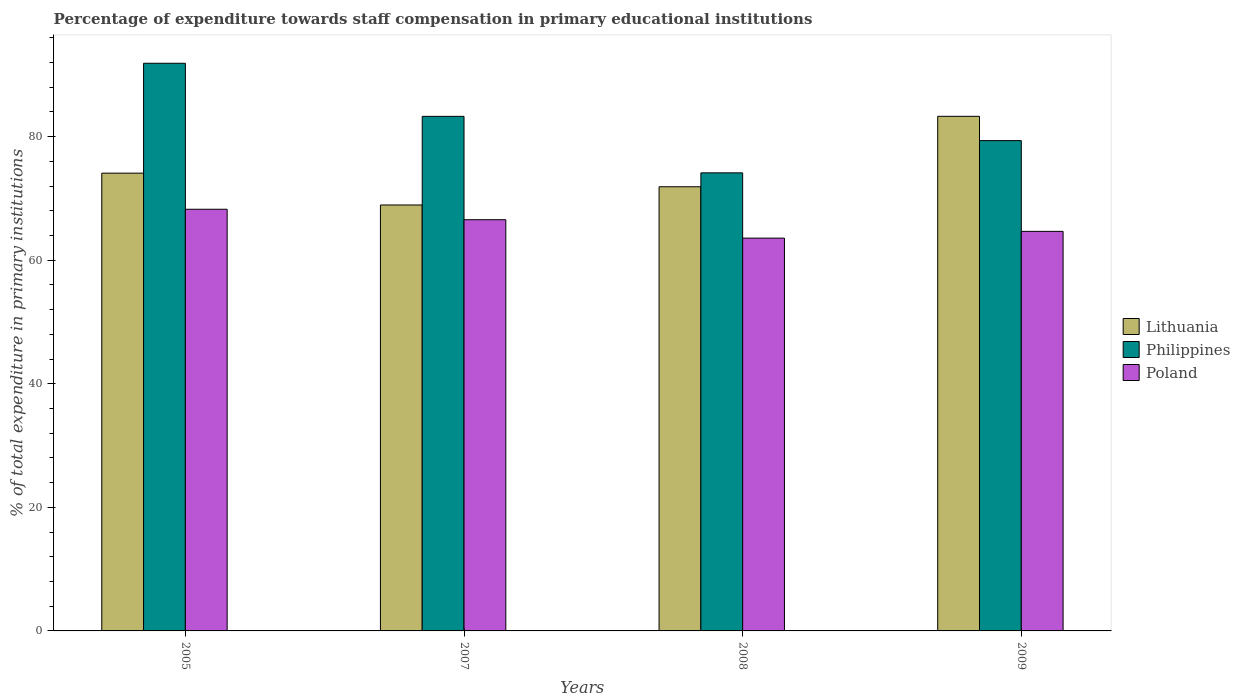How many different coloured bars are there?
Ensure brevity in your answer.  3. How many groups of bars are there?
Give a very brief answer. 4. Are the number of bars per tick equal to the number of legend labels?
Provide a succinct answer. Yes. Are the number of bars on each tick of the X-axis equal?
Offer a very short reply. Yes. What is the label of the 1st group of bars from the left?
Ensure brevity in your answer.  2005. What is the percentage of expenditure towards staff compensation in Poland in 2005?
Make the answer very short. 68.25. Across all years, what is the maximum percentage of expenditure towards staff compensation in Lithuania?
Keep it short and to the point. 83.29. Across all years, what is the minimum percentage of expenditure towards staff compensation in Lithuania?
Provide a succinct answer. 68.94. In which year was the percentage of expenditure towards staff compensation in Poland maximum?
Your answer should be compact. 2005. What is the total percentage of expenditure towards staff compensation in Poland in the graph?
Provide a short and direct response. 263.04. What is the difference between the percentage of expenditure towards staff compensation in Philippines in 2007 and that in 2008?
Make the answer very short. 9.14. What is the difference between the percentage of expenditure towards staff compensation in Philippines in 2007 and the percentage of expenditure towards staff compensation in Poland in 2009?
Offer a terse response. 18.61. What is the average percentage of expenditure towards staff compensation in Lithuania per year?
Your answer should be compact. 74.55. In the year 2008, what is the difference between the percentage of expenditure towards staff compensation in Philippines and percentage of expenditure towards staff compensation in Lithuania?
Your answer should be very brief. 2.25. In how many years, is the percentage of expenditure towards staff compensation in Lithuania greater than 76 %?
Ensure brevity in your answer.  1. What is the ratio of the percentage of expenditure towards staff compensation in Lithuania in 2008 to that in 2009?
Give a very brief answer. 0.86. What is the difference between the highest and the second highest percentage of expenditure towards staff compensation in Philippines?
Make the answer very short. 8.59. What is the difference between the highest and the lowest percentage of expenditure towards staff compensation in Lithuania?
Your answer should be very brief. 14.35. In how many years, is the percentage of expenditure towards staff compensation in Philippines greater than the average percentage of expenditure towards staff compensation in Philippines taken over all years?
Offer a terse response. 2. What does the 3rd bar from the right in 2009 represents?
Your answer should be compact. Lithuania. How many bars are there?
Your response must be concise. 12. Are all the bars in the graph horizontal?
Keep it short and to the point. No. How many years are there in the graph?
Offer a terse response. 4. Are the values on the major ticks of Y-axis written in scientific E-notation?
Provide a succinct answer. No. How are the legend labels stacked?
Your answer should be very brief. Vertical. What is the title of the graph?
Provide a short and direct response. Percentage of expenditure towards staff compensation in primary educational institutions. What is the label or title of the X-axis?
Give a very brief answer. Years. What is the label or title of the Y-axis?
Keep it short and to the point. % of total expenditure in primary institutions. What is the % of total expenditure in primary institutions in Lithuania in 2005?
Ensure brevity in your answer.  74.09. What is the % of total expenditure in primary institutions in Philippines in 2005?
Ensure brevity in your answer.  91.88. What is the % of total expenditure in primary institutions of Poland in 2005?
Provide a succinct answer. 68.25. What is the % of total expenditure in primary institutions in Lithuania in 2007?
Provide a succinct answer. 68.94. What is the % of total expenditure in primary institutions in Philippines in 2007?
Offer a very short reply. 83.28. What is the % of total expenditure in primary institutions in Poland in 2007?
Make the answer very short. 66.55. What is the % of total expenditure in primary institutions of Lithuania in 2008?
Your answer should be very brief. 71.89. What is the % of total expenditure in primary institutions in Philippines in 2008?
Offer a very short reply. 74.14. What is the % of total expenditure in primary institutions in Poland in 2008?
Ensure brevity in your answer.  63.57. What is the % of total expenditure in primary institutions of Lithuania in 2009?
Your response must be concise. 83.29. What is the % of total expenditure in primary institutions of Philippines in 2009?
Offer a very short reply. 79.35. What is the % of total expenditure in primary institutions in Poland in 2009?
Keep it short and to the point. 64.67. Across all years, what is the maximum % of total expenditure in primary institutions of Lithuania?
Make the answer very short. 83.29. Across all years, what is the maximum % of total expenditure in primary institutions of Philippines?
Your response must be concise. 91.88. Across all years, what is the maximum % of total expenditure in primary institutions of Poland?
Offer a very short reply. 68.25. Across all years, what is the minimum % of total expenditure in primary institutions of Lithuania?
Keep it short and to the point. 68.94. Across all years, what is the minimum % of total expenditure in primary institutions of Philippines?
Provide a succinct answer. 74.14. Across all years, what is the minimum % of total expenditure in primary institutions of Poland?
Provide a short and direct response. 63.57. What is the total % of total expenditure in primary institutions of Lithuania in the graph?
Provide a short and direct response. 298.2. What is the total % of total expenditure in primary institutions of Philippines in the graph?
Ensure brevity in your answer.  328.65. What is the total % of total expenditure in primary institutions in Poland in the graph?
Offer a very short reply. 263.04. What is the difference between the % of total expenditure in primary institutions of Lithuania in 2005 and that in 2007?
Keep it short and to the point. 5.15. What is the difference between the % of total expenditure in primary institutions of Philippines in 2005 and that in 2007?
Keep it short and to the point. 8.59. What is the difference between the % of total expenditure in primary institutions of Poland in 2005 and that in 2007?
Your response must be concise. 1.69. What is the difference between the % of total expenditure in primary institutions of Lithuania in 2005 and that in 2008?
Your response must be concise. 2.2. What is the difference between the % of total expenditure in primary institutions in Philippines in 2005 and that in 2008?
Give a very brief answer. 17.74. What is the difference between the % of total expenditure in primary institutions of Poland in 2005 and that in 2008?
Provide a short and direct response. 4.67. What is the difference between the % of total expenditure in primary institutions in Lithuania in 2005 and that in 2009?
Provide a succinct answer. -9.2. What is the difference between the % of total expenditure in primary institutions of Philippines in 2005 and that in 2009?
Keep it short and to the point. 12.52. What is the difference between the % of total expenditure in primary institutions in Poland in 2005 and that in 2009?
Provide a succinct answer. 3.58. What is the difference between the % of total expenditure in primary institutions of Lithuania in 2007 and that in 2008?
Make the answer very short. -2.95. What is the difference between the % of total expenditure in primary institutions of Philippines in 2007 and that in 2008?
Offer a terse response. 9.14. What is the difference between the % of total expenditure in primary institutions in Poland in 2007 and that in 2008?
Offer a terse response. 2.98. What is the difference between the % of total expenditure in primary institutions in Lithuania in 2007 and that in 2009?
Provide a succinct answer. -14.35. What is the difference between the % of total expenditure in primary institutions in Philippines in 2007 and that in 2009?
Give a very brief answer. 3.93. What is the difference between the % of total expenditure in primary institutions of Poland in 2007 and that in 2009?
Give a very brief answer. 1.89. What is the difference between the % of total expenditure in primary institutions of Lithuania in 2008 and that in 2009?
Provide a succinct answer. -11.4. What is the difference between the % of total expenditure in primary institutions in Philippines in 2008 and that in 2009?
Keep it short and to the point. -5.22. What is the difference between the % of total expenditure in primary institutions in Poland in 2008 and that in 2009?
Your response must be concise. -1.09. What is the difference between the % of total expenditure in primary institutions of Lithuania in 2005 and the % of total expenditure in primary institutions of Philippines in 2007?
Offer a very short reply. -9.19. What is the difference between the % of total expenditure in primary institutions in Lithuania in 2005 and the % of total expenditure in primary institutions in Poland in 2007?
Give a very brief answer. 7.54. What is the difference between the % of total expenditure in primary institutions of Philippines in 2005 and the % of total expenditure in primary institutions of Poland in 2007?
Offer a terse response. 25.32. What is the difference between the % of total expenditure in primary institutions in Lithuania in 2005 and the % of total expenditure in primary institutions in Philippines in 2008?
Provide a short and direct response. -0.05. What is the difference between the % of total expenditure in primary institutions in Lithuania in 2005 and the % of total expenditure in primary institutions in Poland in 2008?
Ensure brevity in your answer.  10.51. What is the difference between the % of total expenditure in primary institutions of Philippines in 2005 and the % of total expenditure in primary institutions of Poland in 2008?
Give a very brief answer. 28.3. What is the difference between the % of total expenditure in primary institutions of Lithuania in 2005 and the % of total expenditure in primary institutions of Philippines in 2009?
Keep it short and to the point. -5.27. What is the difference between the % of total expenditure in primary institutions in Lithuania in 2005 and the % of total expenditure in primary institutions in Poland in 2009?
Your answer should be very brief. 9.42. What is the difference between the % of total expenditure in primary institutions of Philippines in 2005 and the % of total expenditure in primary institutions of Poland in 2009?
Your response must be concise. 27.21. What is the difference between the % of total expenditure in primary institutions of Lithuania in 2007 and the % of total expenditure in primary institutions of Philippines in 2008?
Your response must be concise. -5.2. What is the difference between the % of total expenditure in primary institutions in Lithuania in 2007 and the % of total expenditure in primary institutions in Poland in 2008?
Your answer should be compact. 5.36. What is the difference between the % of total expenditure in primary institutions of Philippines in 2007 and the % of total expenditure in primary institutions of Poland in 2008?
Your answer should be compact. 19.71. What is the difference between the % of total expenditure in primary institutions of Lithuania in 2007 and the % of total expenditure in primary institutions of Philippines in 2009?
Make the answer very short. -10.42. What is the difference between the % of total expenditure in primary institutions of Lithuania in 2007 and the % of total expenditure in primary institutions of Poland in 2009?
Make the answer very short. 4.27. What is the difference between the % of total expenditure in primary institutions in Philippines in 2007 and the % of total expenditure in primary institutions in Poland in 2009?
Keep it short and to the point. 18.61. What is the difference between the % of total expenditure in primary institutions of Lithuania in 2008 and the % of total expenditure in primary institutions of Philippines in 2009?
Give a very brief answer. -7.47. What is the difference between the % of total expenditure in primary institutions in Lithuania in 2008 and the % of total expenditure in primary institutions in Poland in 2009?
Your answer should be compact. 7.22. What is the difference between the % of total expenditure in primary institutions in Philippines in 2008 and the % of total expenditure in primary institutions in Poland in 2009?
Ensure brevity in your answer.  9.47. What is the average % of total expenditure in primary institutions in Lithuania per year?
Provide a short and direct response. 74.55. What is the average % of total expenditure in primary institutions of Philippines per year?
Ensure brevity in your answer.  82.16. What is the average % of total expenditure in primary institutions in Poland per year?
Your response must be concise. 65.76. In the year 2005, what is the difference between the % of total expenditure in primary institutions in Lithuania and % of total expenditure in primary institutions in Philippines?
Your answer should be very brief. -17.79. In the year 2005, what is the difference between the % of total expenditure in primary institutions in Lithuania and % of total expenditure in primary institutions in Poland?
Ensure brevity in your answer.  5.84. In the year 2005, what is the difference between the % of total expenditure in primary institutions of Philippines and % of total expenditure in primary institutions of Poland?
Your response must be concise. 23.63. In the year 2007, what is the difference between the % of total expenditure in primary institutions in Lithuania and % of total expenditure in primary institutions in Philippines?
Give a very brief answer. -14.34. In the year 2007, what is the difference between the % of total expenditure in primary institutions in Lithuania and % of total expenditure in primary institutions in Poland?
Offer a terse response. 2.38. In the year 2007, what is the difference between the % of total expenditure in primary institutions of Philippines and % of total expenditure in primary institutions of Poland?
Ensure brevity in your answer.  16.73. In the year 2008, what is the difference between the % of total expenditure in primary institutions in Lithuania and % of total expenditure in primary institutions in Philippines?
Your response must be concise. -2.25. In the year 2008, what is the difference between the % of total expenditure in primary institutions in Lithuania and % of total expenditure in primary institutions in Poland?
Your answer should be very brief. 8.31. In the year 2008, what is the difference between the % of total expenditure in primary institutions in Philippines and % of total expenditure in primary institutions in Poland?
Ensure brevity in your answer.  10.56. In the year 2009, what is the difference between the % of total expenditure in primary institutions in Lithuania and % of total expenditure in primary institutions in Philippines?
Keep it short and to the point. 3.93. In the year 2009, what is the difference between the % of total expenditure in primary institutions in Lithuania and % of total expenditure in primary institutions in Poland?
Your answer should be very brief. 18.62. In the year 2009, what is the difference between the % of total expenditure in primary institutions of Philippines and % of total expenditure in primary institutions of Poland?
Your answer should be compact. 14.69. What is the ratio of the % of total expenditure in primary institutions in Lithuania in 2005 to that in 2007?
Offer a terse response. 1.07. What is the ratio of the % of total expenditure in primary institutions of Philippines in 2005 to that in 2007?
Ensure brevity in your answer.  1.1. What is the ratio of the % of total expenditure in primary institutions in Poland in 2005 to that in 2007?
Provide a succinct answer. 1.03. What is the ratio of the % of total expenditure in primary institutions in Lithuania in 2005 to that in 2008?
Your response must be concise. 1.03. What is the ratio of the % of total expenditure in primary institutions in Philippines in 2005 to that in 2008?
Keep it short and to the point. 1.24. What is the ratio of the % of total expenditure in primary institutions of Poland in 2005 to that in 2008?
Your answer should be compact. 1.07. What is the ratio of the % of total expenditure in primary institutions in Lithuania in 2005 to that in 2009?
Make the answer very short. 0.89. What is the ratio of the % of total expenditure in primary institutions in Philippines in 2005 to that in 2009?
Your response must be concise. 1.16. What is the ratio of the % of total expenditure in primary institutions of Poland in 2005 to that in 2009?
Your answer should be very brief. 1.06. What is the ratio of the % of total expenditure in primary institutions in Philippines in 2007 to that in 2008?
Offer a very short reply. 1.12. What is the ratio of the % of total expenditure in primary institutions of Poland in 2007 to that in 2008?
Provide a succinct answer. 1.05. What is the ratio of the % of total expenditure in primary institutions in Lithuania in 2007 to that in 2009?
Your answer should be compact. 0.83. What is the ratio of the % of total expenditure in primary institutions in Philippines in 2007 to that in 2009?
Provide a short and direct response. 1.05. What is the ratio of the % of total expenditure in primary institutions in Poland in 2007 to that in 2009?
Keep it short and to the point. 1.03. What is the ratio of the % of total expenditure in primary institutions in Lithuania in 2008 to that in 2009?
Keep it short and to the point. 0.86. What is the ratio of the % of total expenditure in primary institutions in Philippines in 2008 to that in 2009?
Your answer should be compact. 0.93. What is the ratio of the % of total expenditure in primary institutions of Poland in 2008 to that in 2009?
Provide a succinct answer. 0.98. What is the difference between the highest and the second highest % of total expenditure in primary institutions of Lithuania?
Your response must be concise. 9.2. What is the difference between the highest and the second highest % of total expenditure in primary institutions in Philippines?
Offer a terse response. 8.59. What is the difference between the highest and the second highest % of total expenditure in primary institutions of Poland?
Your response must be concise. 1.69. What is the difference between the highest and the lowest % of total expenditure in primary institutions of Lithuania?
Offer a terse response. 14.35. What is the difference between the highest and the lowest % of total expenditure in primary institutions in Philippines?
Provide a short and direct response. 17.74. What is the difference between the highest and the lowest % of total expenditure in primary institutions of Poland?
Keep it short and to the point. 4.67. 